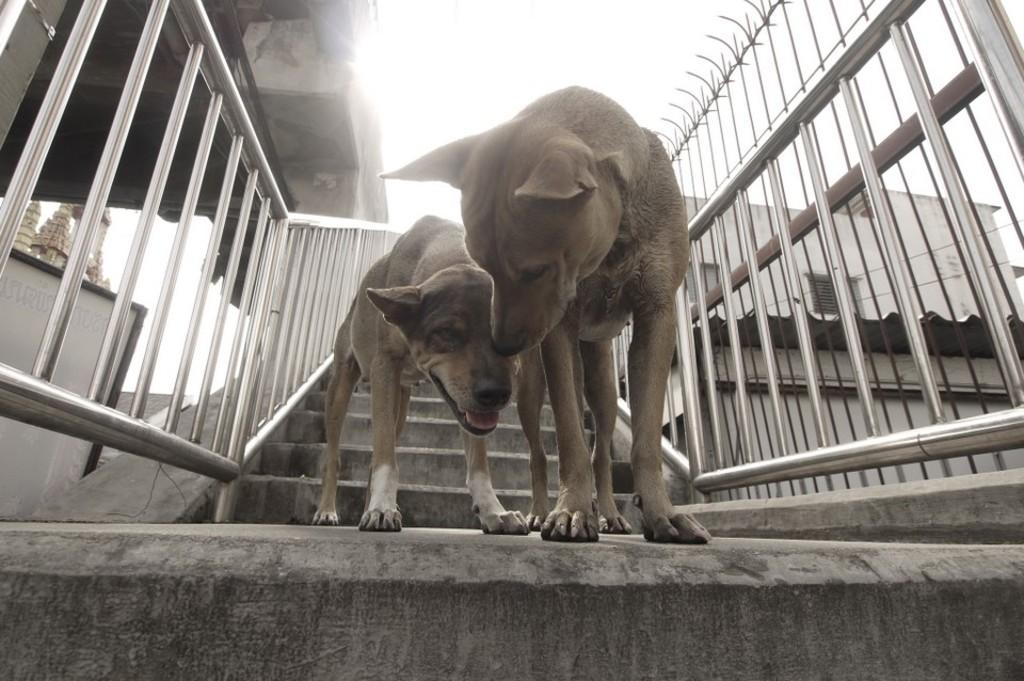How many dogs are in the image? There are two dogs in the image. What are the dogs doing in the image? The dogs are standing on a staircase. What can be seen on either side of the dogs? There are hand-grills on either side of the image. What is visible in the background of the image? There are buildings in the background of the image. Can you see a yak in the image? No, there is no yak present in the image. Is there a cave visible in the background of the image? No, there is no cave visible in the image; only buildings are present in the background. 